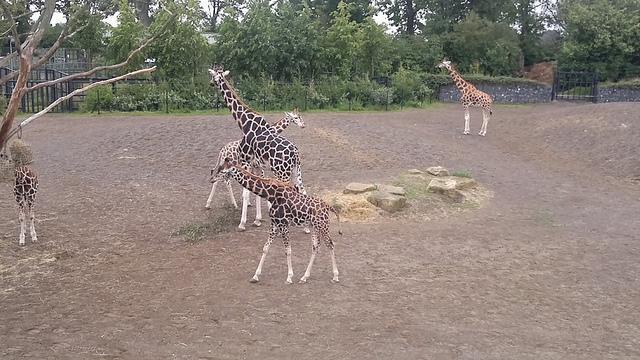How many animals are there?
Give a very brief answer. 5. How many giraffes can be seen?
Give a very brief answer. 3. 